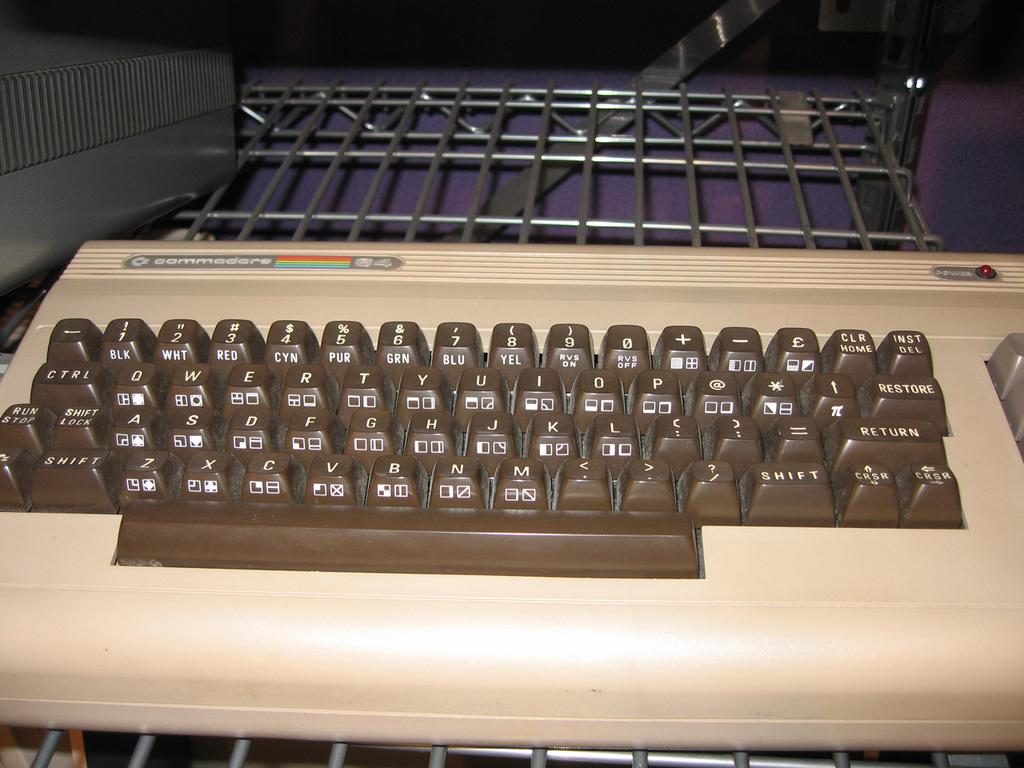<image>
Provide a brief description of the given image. A brown and beige keyboard with the logo for commodore on the top left. 